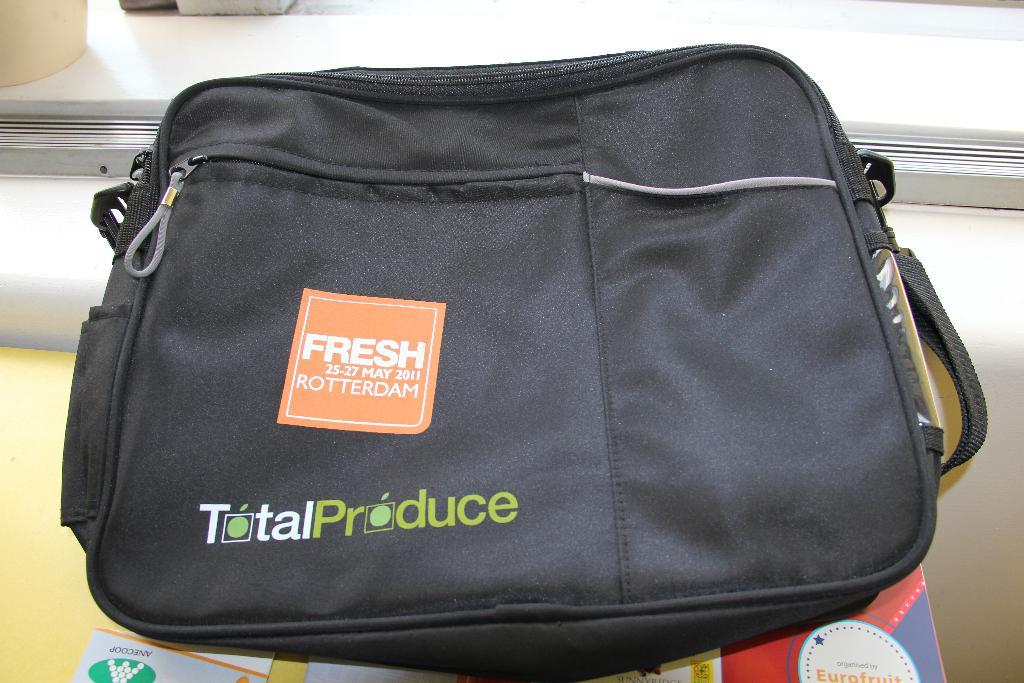What is the color of the bag in the image? The bag in the image is black. How is the black bag being emphasized in the image? The black bag is highlighted in the image. What type of gold object is visible in the image? There is no gold object present in the image. How many flies can be seen on the black bag in the image? There are no flies present in the image. 